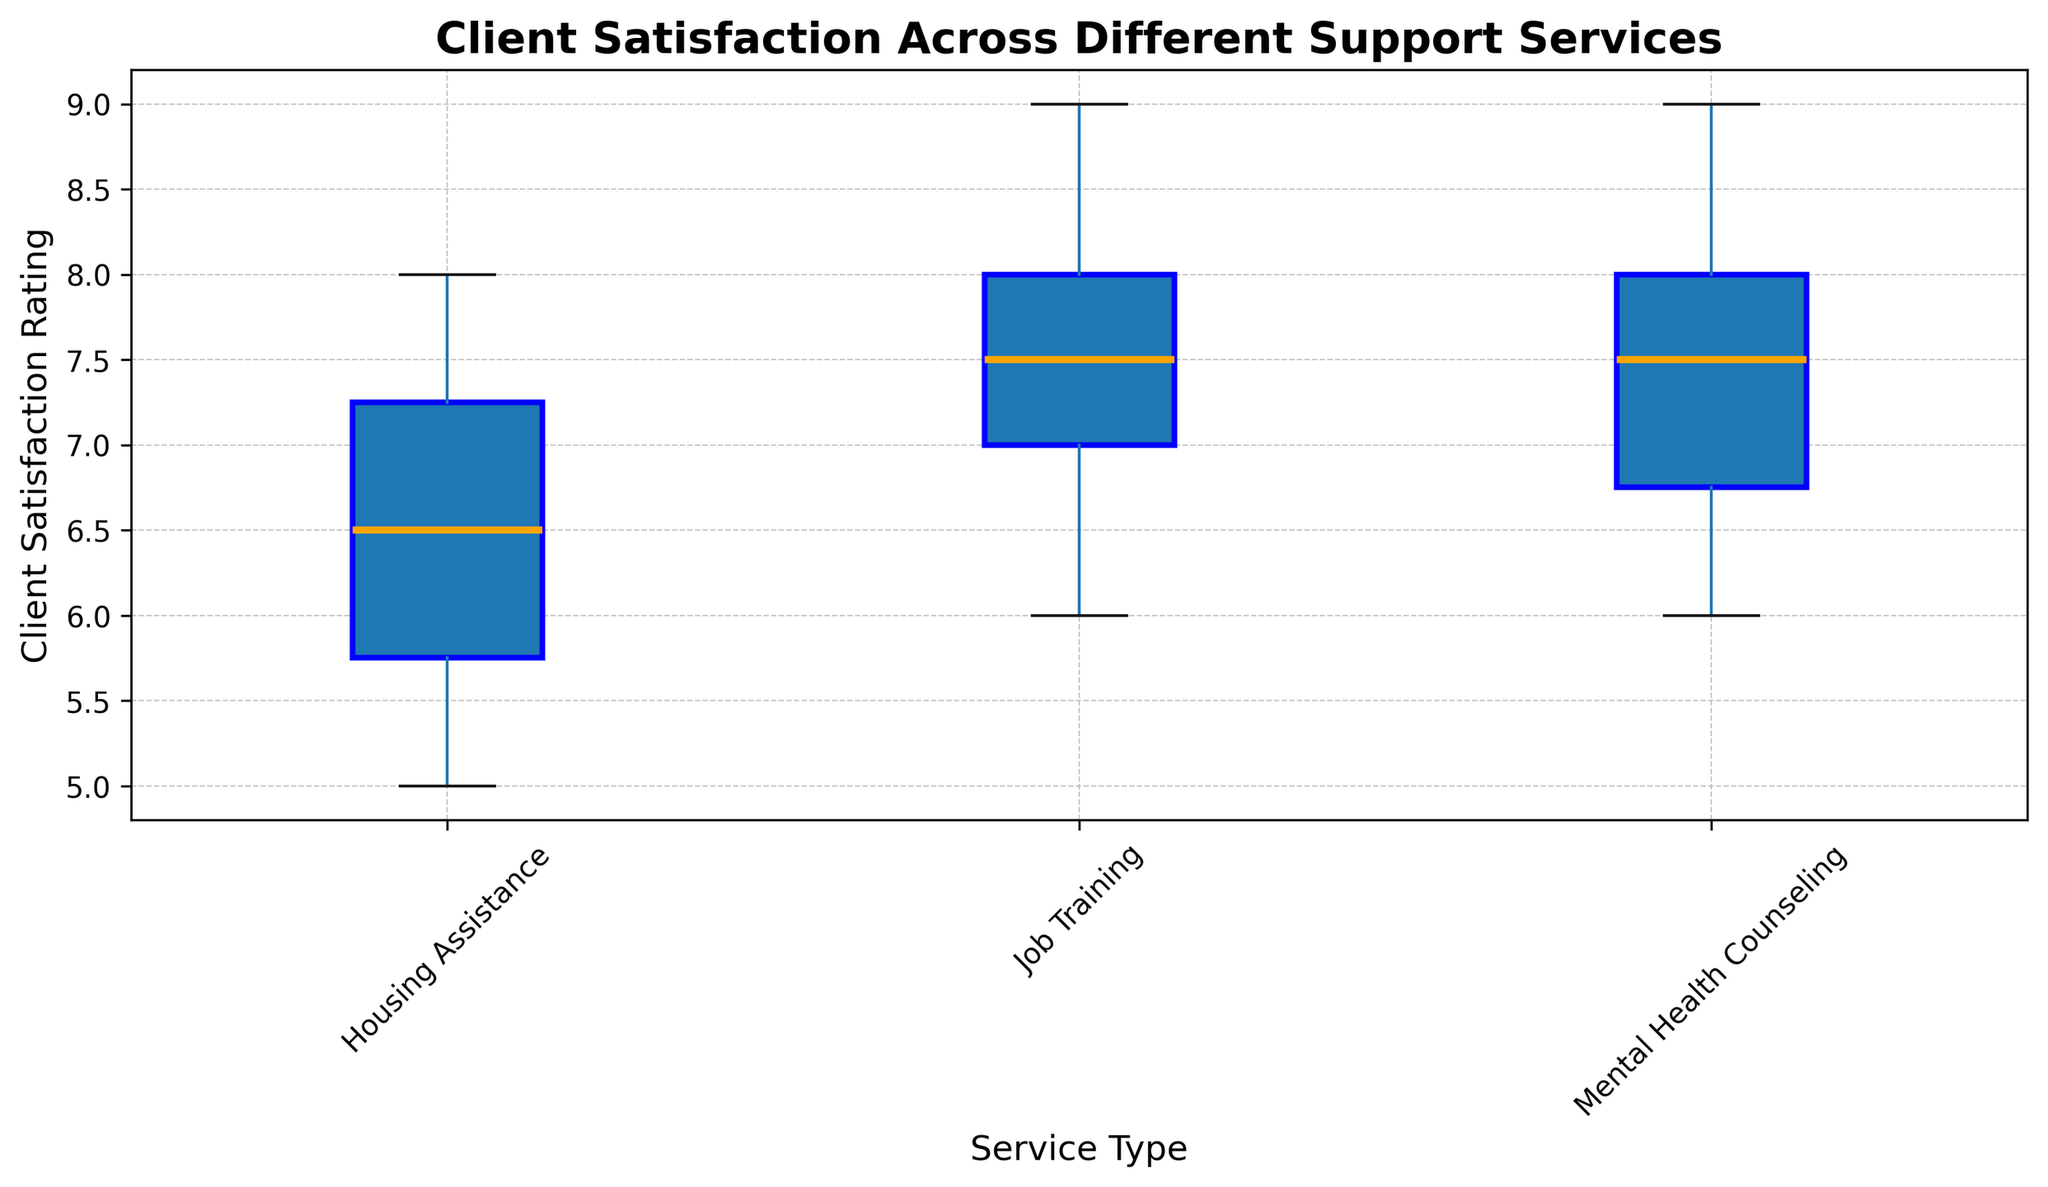What's the median client satisfaction rating for Mental Health Counseling? To find the median value, which is the middle value in the sorted list, look at the box plot for Mental Health Counseling and locate the line inside the box.
Answer: 7 Which support service has the highest median client satisfaction rating? To determine the highest median, compare the median lines within the boxes of the different services. The line inside the box shows the median value.
Answer: Job Training Which service has the most consistent client satisfaction ratings (least variability)? Identify the service with the smallest interquartile range (IQR), represented by the middle 50% of the data points within the box. The smallest box indicates the least variability.
Answer: Housing Assistance Is the median client satisfaction rating for Housing Assistance higher or lower than that for Mental Health Counseling? Compare the median lines within the boxes of Housing Assistance and Mental Health Counseling. The higher median line indicates a higher median satisfaction rating.
Answer: Lower What is the range of client satisfaction ratings for Job Training? The range is determined by looking at the lowest and highest points (whiskers) on the box plot for Job Training.
Answer: 6 to 9 Which support service shows outliers in client satisfaction ratings? Outliers are represented by points outside the whiskers of the box plot. Check each service type for these points.
Answer: None What’s the difference in median client satisfaction ratings between the highest and lowest rated services? Find the highest and lowest median lines among the services. Subtract the lowest median value from the highest median value.
Answer: 7 (Job Training), 6.5 (Housing Assistance). Difference = 0.5 How does the variability in client satisfaction ratings for Mental Health Counseling compare to that for Housing Assistance? Variability can be assessed by comparing the IQR or the height of the boxes. The taller box represents more variability.
Answer: More variable than Housing Assistance 